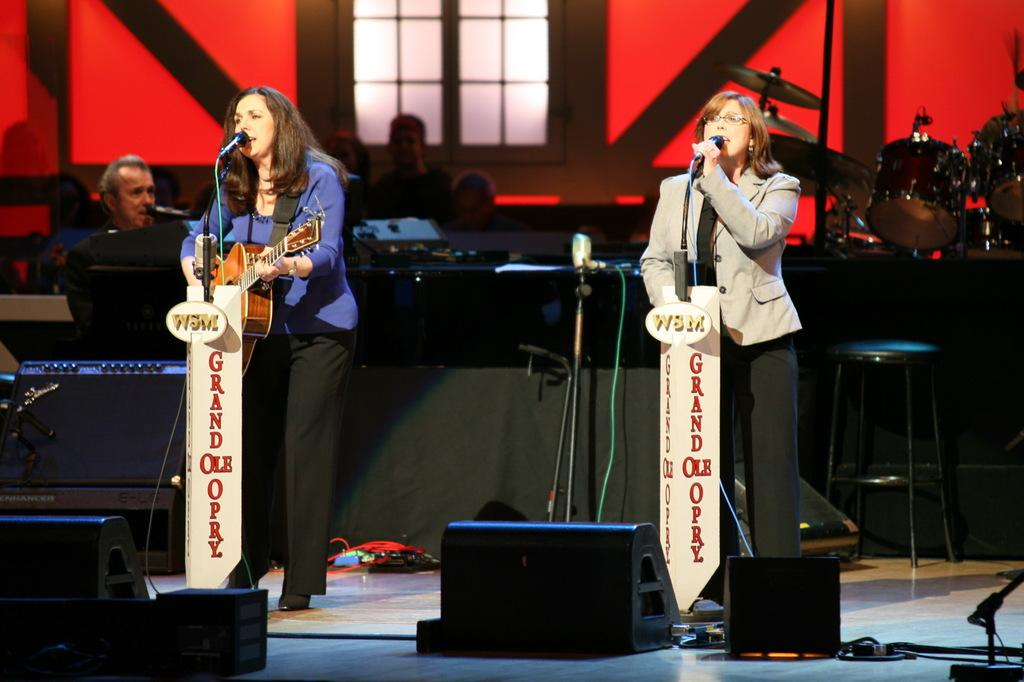What is happening in the image involving a group of people? There is a group of people in the image, and a woman is singing on the right side while another woman is playing a guitar on the left side. What is the woman singing holding? The woman singing is holding a microphone. What instrument is the woman on the left side of the image playing? The woman on the left side of the image is playing a guitar. How many bikes are being kicked by the woman in the image? There are no bikes present in the image, and the woman is not kicking anything. What type of woman is not present in the image? There is no specific type of woman mentioned that is not present in the image. 